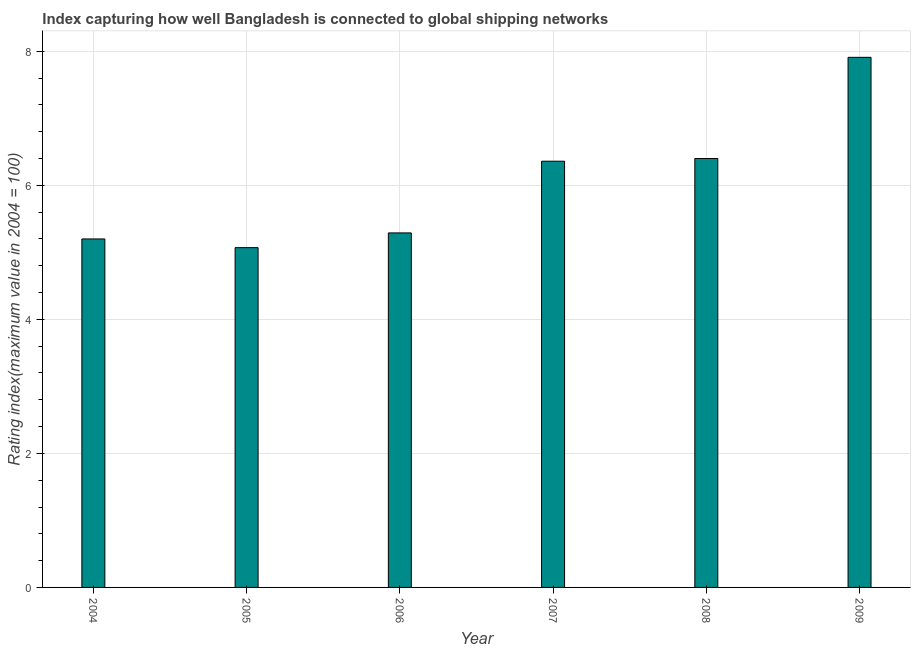Does the graph contain any zero values?
Offer a terse response. No. Does the graph contain grids?
Offer a very short reply. Yes. What is the title of the graph?
Make the answer very short. Index capturing how well Bangladesh is connected to global shipping networks. What is the label or title of the Y-axis?
Provide a succinct answer. Rating index(maximum value in 2004 = 100). What is the liner shipping connectivity index in 2005?
Ensure brevity in your answer.  5.07. Across all years, what is the maximum liner shipping connectivity index?
Ensure brevity in your answer.  7.91. Across all years, what is the minimum liner shipping connectivity index?
Your answer should be very brief. 5.07. In which year was the liner shipping connectivity index minimum?
Your response must be concise. 2005. What is the sum of the liner shipping connectivity index?
Make the answer very short. 36.23. What is the difference between the liner shipping connectivity index in 2004 and 2005?
Make the answer very short. 0.13. What is the average liner shipping connectivity index per year?
Ensure brevity in your answer.  6.04. What is the median liner shipping connectivity index?
Your answer should be compact. 5.83. Is the liner shipping connectivity index in 2006 less than that in 2008?
Ensure brevity in your answer.  Yes. Is the difference between the liner shipping connectivity index in 2006 and 2007 greater than the difference between any two years?
Give a very brief answer. No. What is the difference between the highest and the second highest liner shipping connectivity index?
Give a very brief answer. 1.51. What is the difference between the highest and the lowest liner shipping connectivity index?
Offer a very short reply. 2.84. In how many years, is the liner shipping connectivity index greater than the average liner shipping connectivity index taken over all years?
Your answer should be compact. 3. Are all the bars in the graph horizontal?
Your answer should be very brief. No. What is the difference between two consecutive major ticks on the Y-axis?
Keep it short and to the point. 2. Are the values on the major ticks of Y-axis written in scientific E-notation?
Give a very brief answer. No. What is the Rating index(maximum value in 2004 = 100) of 2004?
Make the answer very short. 5.2. What is the Rating index(maximum value in 2004 = 100) of 2005?
Give a very brief answer. 5.07. What is the Rating index(maximum value in 2004 = 100) in 2006?
Keep it short and to the point. 5.29. What is the Rating index(maximum value in 2004 = 100) of 2007?
Keep it short and to the point. 6.36. What is the Rating index(maximum value in 2004 = 100) in 2008?
Provide a succinct answer. 6.4. What is the Rating index(maximum value in 2004 = 100) in 2009?
Make the answer very short. 7.91. What is the difference between the Rating index(maximum value in 2004 = 100) in 2004 and 2005?
Provide a succinct answer. 0.13. What is the difference between the Rating index(maximum value in 2004 = 100) in 2004 and 2006?
Offer a very short reply. -0.09. What is the difference between the Rating index(maximum value in 2004 = 100) in 2004 and 2007?
Ensure brevity in your answer.  -1.16. What is the difference between the Rating index(maximum value in 2004 = 100) in 2004 and 2009?
Keep it short and to the point. -2.71. What is the difference between the Rating index(maximum value in 2004 = 100) in 2005 and 2006?
Your answer should be compact. -0.22. What is the difference between the Rating index(maximum value in 2004 = 100) in 2005 and 2007?
Your response must be concise. -1.29. What is the difference between the Rating index(maximum value in 2004 = 100) in 2005 and 2008?
Offer a terse response. -1.33. What is the difference between the Rating index(maximum value in 2004 = 100) in 2005 and 2009?
Ensure brevity in your answer.  -2.84. What is the difference between the Rating index(maximum value in 2004 = 100) in 2006 and 2007?
Your answer should be very brief. -1.07. What is the difference between the Rating index(maximum value in 2004 = 100) in 2006 and 2008?
Offer a terse response. -1.11. What is the difference between the Rating index(maximum value in 2004 = 100) in 2006 and 2009?
Your response must be concise. -2.62. What is the difference between the Rating index(maximum value in 2004 = 100) in 2007 and 2008?
Provide a succinct answer. -0.04. What is the difference between the Rating index(maximum value in 2004 = 100) in 2007 and 2009?
Make the answer very short. -1.55. What is the difference between the Rating index(maximum value in 2004 = 100) in 2008 and 2009?
Your answer should be very brief. -1.51. What is the ratio of the Rating index(maximum value in 2004 = 100) in 2004 to that in 2006?
Your answer should be compact. 0.98. What is the ratio of the Rating index(maximum value in 2004 = 100) in 2004 to that in 2007?
Provide a succinct answer. 0.82. What is the ratio of the Rating index(maximum value in 2004 = 100) in 2004 to that in 2008?
Keep it short and to the point. 0.81. What is the ratio of the Rating index(maximum value in 2004 = 100) in 2004 to that in 2009?
Your answer should be very brief. 0.66. What is the ratio of the Rating index(maximum value in 2004 = 100) in 2005 to that in 2006?
Offer a very short reply. 0.96. What is the ratio of the Rating index(maximum value in 2004 = 100) in 2005 to that in 2007?
Provide a short and direct response. 0.8. What is the ratio of the Rating index(maximum value in 2004 = 100) in 2005 to that in 2008?
Keep it short and to the point. 0.79. What is the ratio of the Rating index(maximum value in 2004 = 100) in 2005 to that in 2009?
Your response must be concise. 0.64. What is the ratio of the Rating index(maximum value in 2004 = 100) in 2006 to that in 2007?
Your response must be concise. 0.83. What is the ratio of the Rating index(maximum value in 2004 = 100) in 2006 to that in 2008?
Keep it short and to the point. 0.83. What is the ratio of the Rating index(maximum value in 2004 = 100) in 2006 to that in 2009?
Offer a terse response. 0.67. What is the ratio of the Rating index(maximum value in 2004 = 100) in 2007 to that in 2008?
Provide a short and direct response. 0.99. What is the ratio of the Rating index(maximum value in 2004 = 100) in 2007 to that in 2009?
Provide a succinct answer. 0.8. What is the ratio of the Rating index(maximum value in 2004 = 100) in 2008 to that in 2009?
Your answer should be very brief. 0.81. 